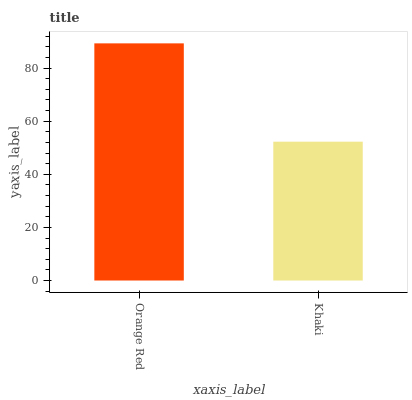Is Khaki the minimum?
Answer yes or no. Yes. Is Orange Red the maximum?
Answer yes or no. Yes. Is Khaki the maximum?
Answer yes or no. No. Is Orange Red greater than Khaki?
Answer yes or no. Yes. Is Khaki less than Orange Red?
Answer yes or no. Yes. Is Khaki greater than Orange Red?
Answer yes or no. No. Is Orange Red less than Khaki?
Answer yes or no. No. Is Orange Red the high median?
Answer yes or no. Yes. Is Khaki the low median?
Answer yes or no. Yes. Is Khaki the high median?
Answer yes or no. No. Is Orange Red the low median?
Answer yes or no. No. 